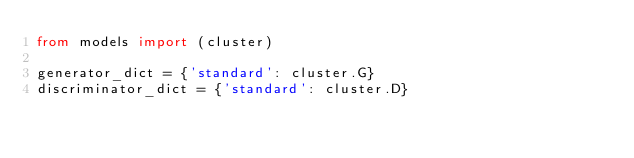<code> <loc_0><loc_0><loc_500><loc_500><_Python_>from models import (cluster)

generator_dict = {'standard': cluster.G}
discriminator_dict = {'standard': cluster.D}
</code> 